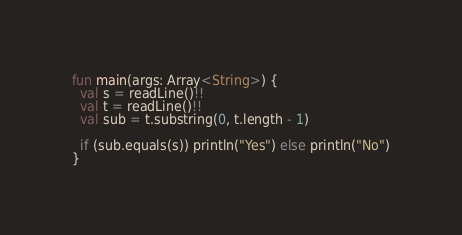Convert code to text. <code><loc_0><loc_0><loc_500><loc_500><_Kotlin_>fun main(args: Array<String>) {
  val s = readLine()!!
  val t = readLine()!! 
  val sub = t.substring(0, t.length - 1)
  
  if (sub.equals(s)) println("Yes") else println("No")
}</code> 